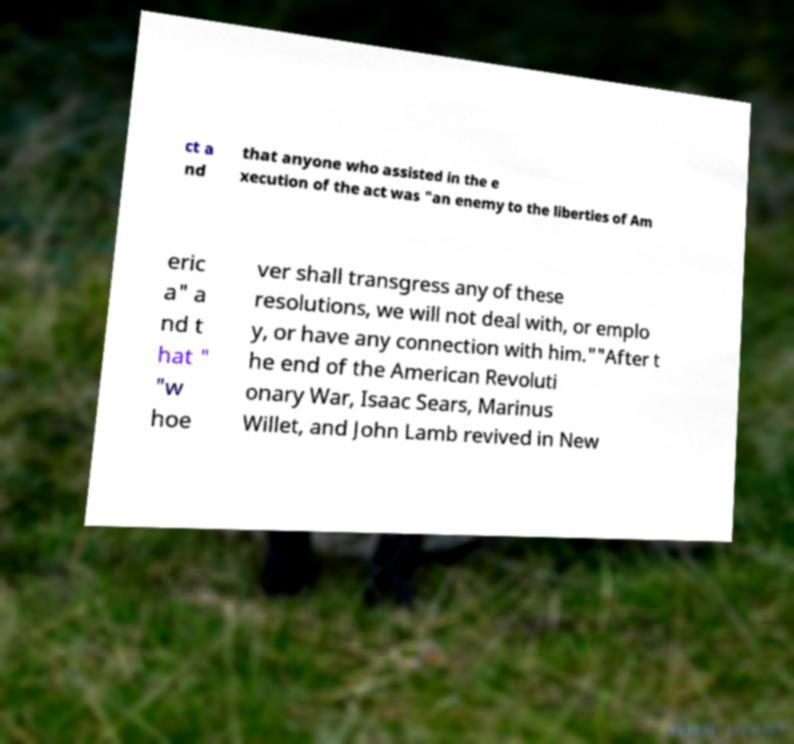For documentation purposes, I need the text within this image transcribed. Could you provide that? ct a nd that anyone who assisted in the e xecution of the act was "an enemy to the liberties of Am eric a" a nd t hat " "w hoe ver shall transgress any of these resolutions, we will not deal with, or emplo y, or have any connection with him.""After t he end of the American Revoluti onary War, Isaac Sears, Marinus Willet, and John Lamb revived in New 